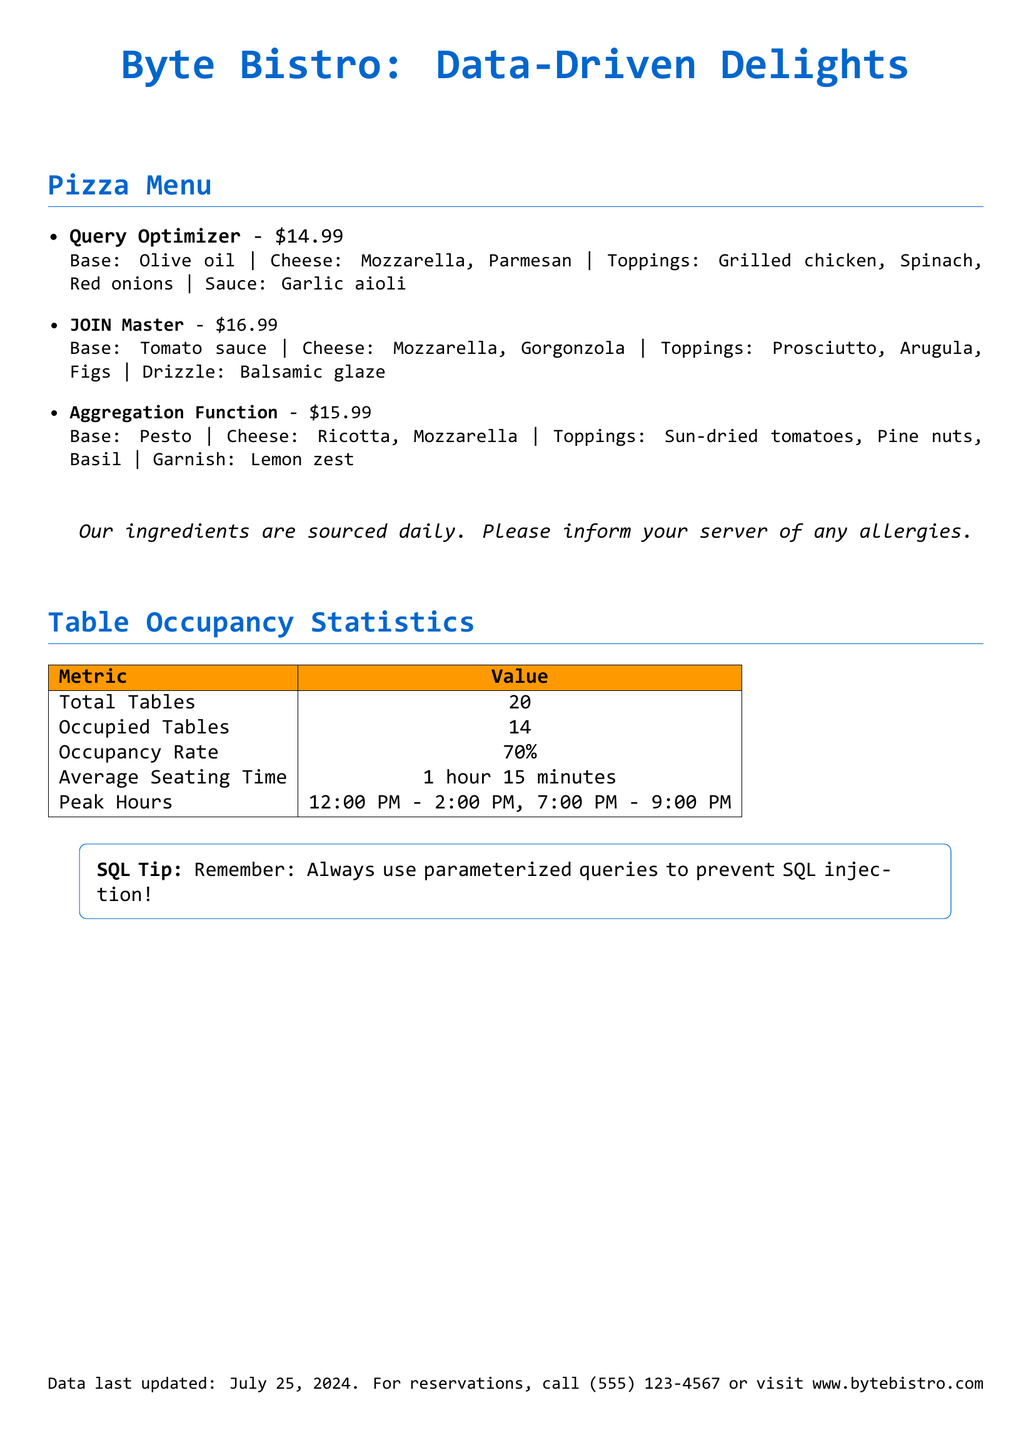What is the price of the Query Optimizer pizza? The price of the Query Optimizer pizza is listed next to the name.
Answer: $14.99 What ingredient is used as the base for the JOIN Master pizza? The base ingredient for the JOIN Master pizza is specified in the description.
Answer: Tomato sauce How many occupied tables are there currently? The number of occupied tables is provided in the occupancy statistics section.
Answer: 14 What is the average seating time for guests? The average seating time is mentioned in the table occupancy statistics.
Answer: 1 hour 15 minutes What toppings are included in the Aggregation Function pizza? The toppings are listed in the description of the Aggregation Function pizza.
Answer: Sun-dried tomatoes, Pine nuts, Basil How many total tables does the restaurant have? The total number of tables is given in the occupancy statistics.
Answer: 20 When are the peak hours for the restaurant? The peak hours are outlined in the occupancy statistics, noted as specific times during the day.
Answer: 12:00 PM - 2:00 PM, 7:00 PM - 9:00 PM What type of cheese is used in the Query Optimizer pizza? The types of cheese used are mentioned in the ingredient list for the Query Optimizer pizza.
Answer: Mozzarella, Parmesan What SQL tip is provided in the menu? The menu includes a note highlighting a SQL best practice related to security.
Answer: Always use parameterized queries to prevent SQL injection! 